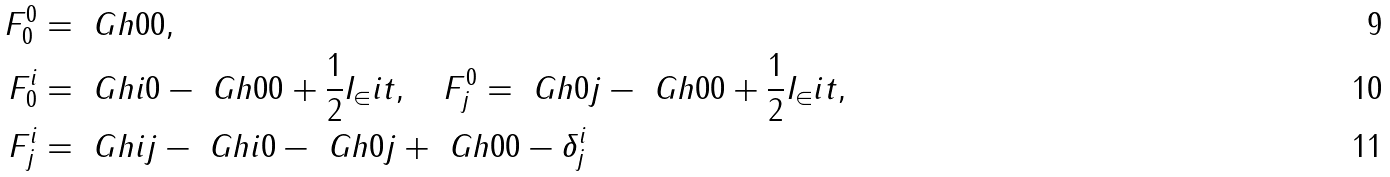<formula> <loc_0><loc_0><loc_500><loc_500>F ^ { 0 } _ { 0 } & = \ G h { 0 } { 0 } , \\ F ^ { i } _ { 0 } & = \ G h { i } { 0 } - \ G h { 0 } { 0 } + \frac { 1 } { 2 } I _ { \in } i t , \quad F ^ { 0 } _ { j } = \ G h { 0 } { j } - \ G h { 0 } { 0 } + \frac { 1 } { 2 } I _ { \in } i t , \\ F ^ { i } _ { j } & = \ G h { i } { j } - \ G h { i } { 0 } - \ G h { 0 } { j } + \ G h { 0 } { 0 } - \delta ^ { i } _ { j }</formula> 